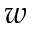<formula> <loc_0><loc_0><loc_500><loc_500>w</formula> 